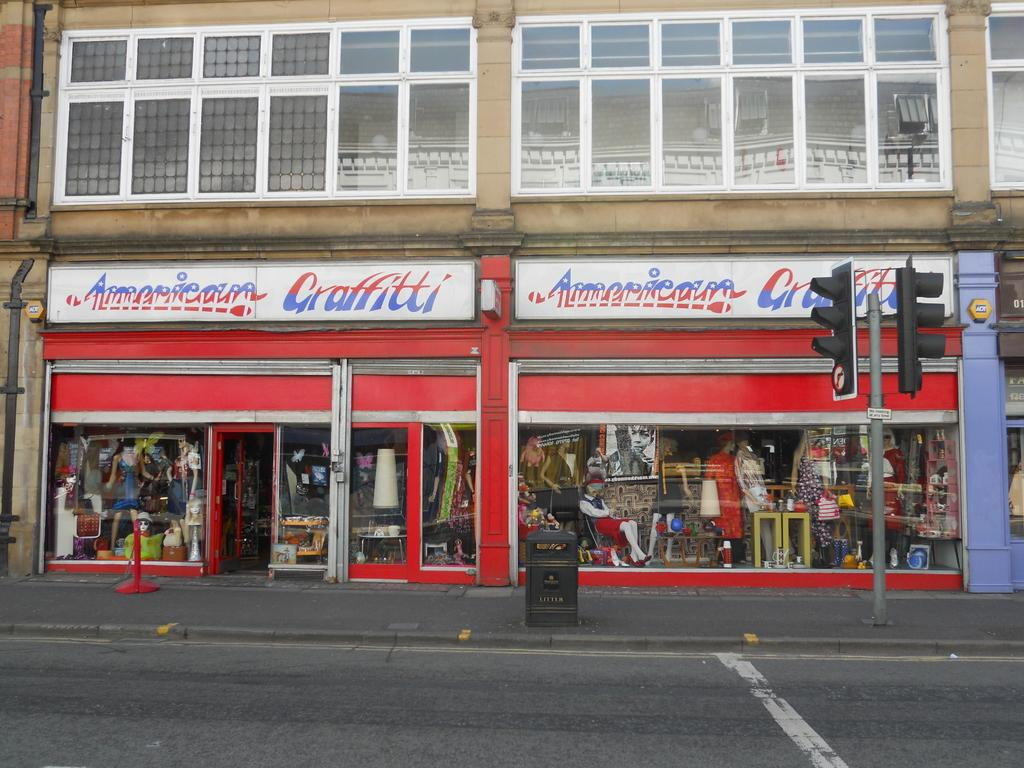What type of structure is visible in the image? There is a building in the image. What objects are present near the building? There are boards, mannequins, glasses, a bin, and a pole visible in the image. What type of signaling devices can be seen in the image? There are traffic signals in the image. What type of surface is visible in the image? There is a road in the image. What type of treatment is being administered to the mannequins in the image? There is no treatment being administered to the mannequins in the image; they are simply objects placed near the building. What book is the mannequin reading in the image? There are no mannequins reading a book in the image, as there are no books present. 